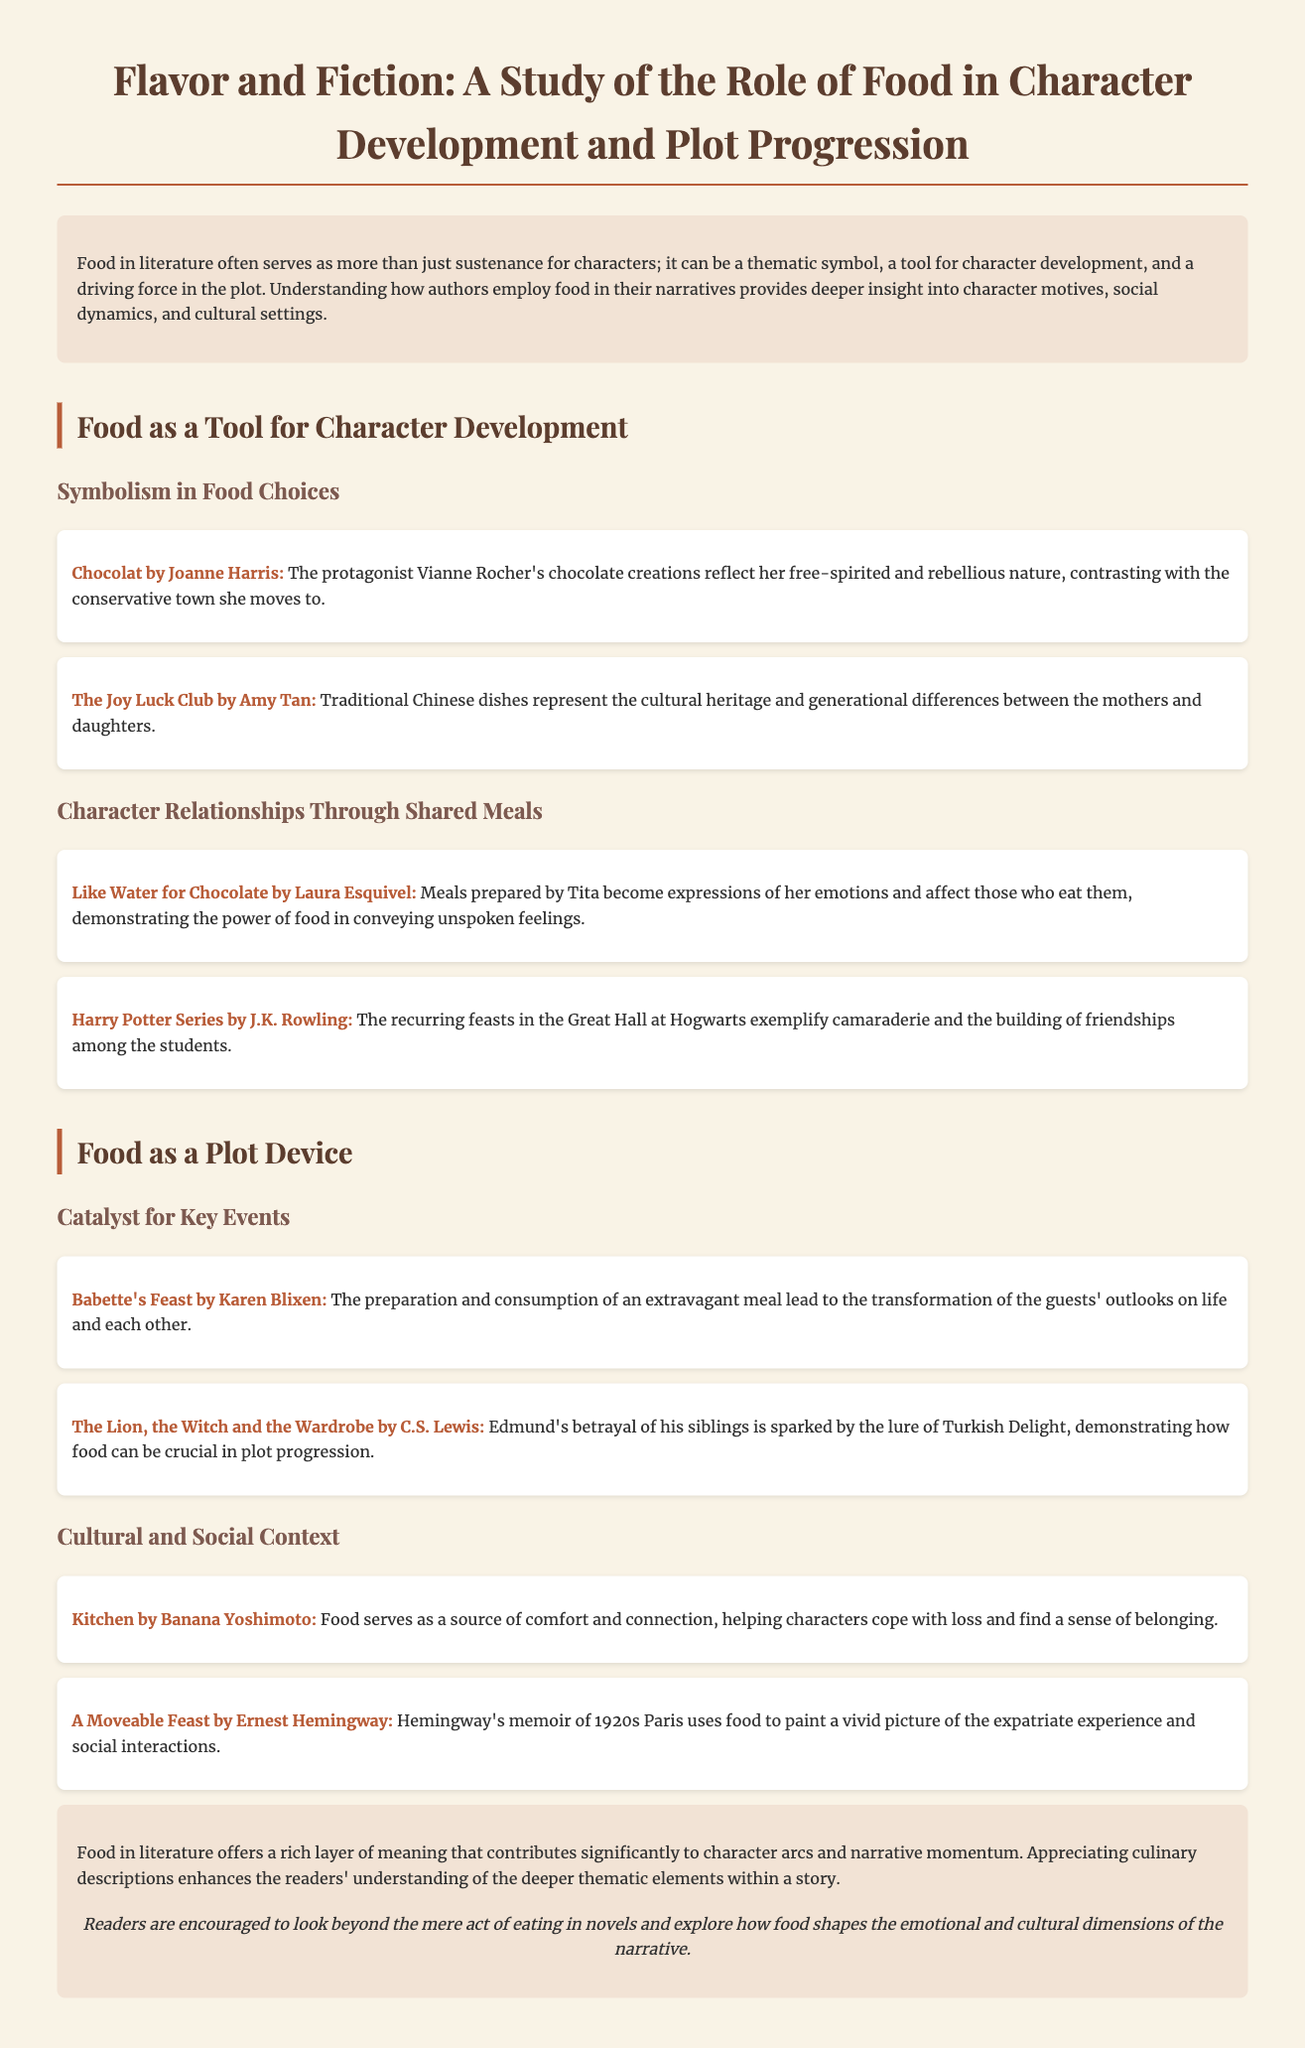What is the title of the study? The title of the study is given at the top of the document.
Answer: Flavor and Fiction: A Study of the Role of Food in Literature Who authored "Chocolat"? The author of "Chocolat" is mentioned in the document as a book example under character development.
Answer: Joanne Harris In which book do meals express unspoken feelings? This book example illustrates how meals convey emotions and is categorized under character relationships.
Answer: Like Water for Chocolate What food item leads to betrayal in "The Lion, the Witch and the Wardrobe"? Mentioned in the context of plot progression, this specific food item is pivotal to the character's actions.
Answer: Turkish Delight What theme is associated with food in "Kitchen"? The relationship between food and emotion is highlighted in the context of character experiences.
Answer: Comfort and connection How does food contribute to character development in "The Joy Luck Club"? The document outlines this book's use of food in representing cultural heritage and generational differences.
Answer: Traditional Chinese dishes What narrative function does the meal in "Babette's Feast" serve? This meal's impact is discussed as a turning point for character perspectives in the story.
Answer: Transformation What does the conclusion suggest about food in literature? The conclusion summarizes the overall importance of food within narratives and character arcs.
Answer: A rich layer of meaning 